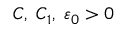Convert formula to latex. <formula><loc_0><loc_0><loc_500><loc_500>C , \, C _ { 1 } , \, \varepsilon _ { 0 } > 0</formula> 